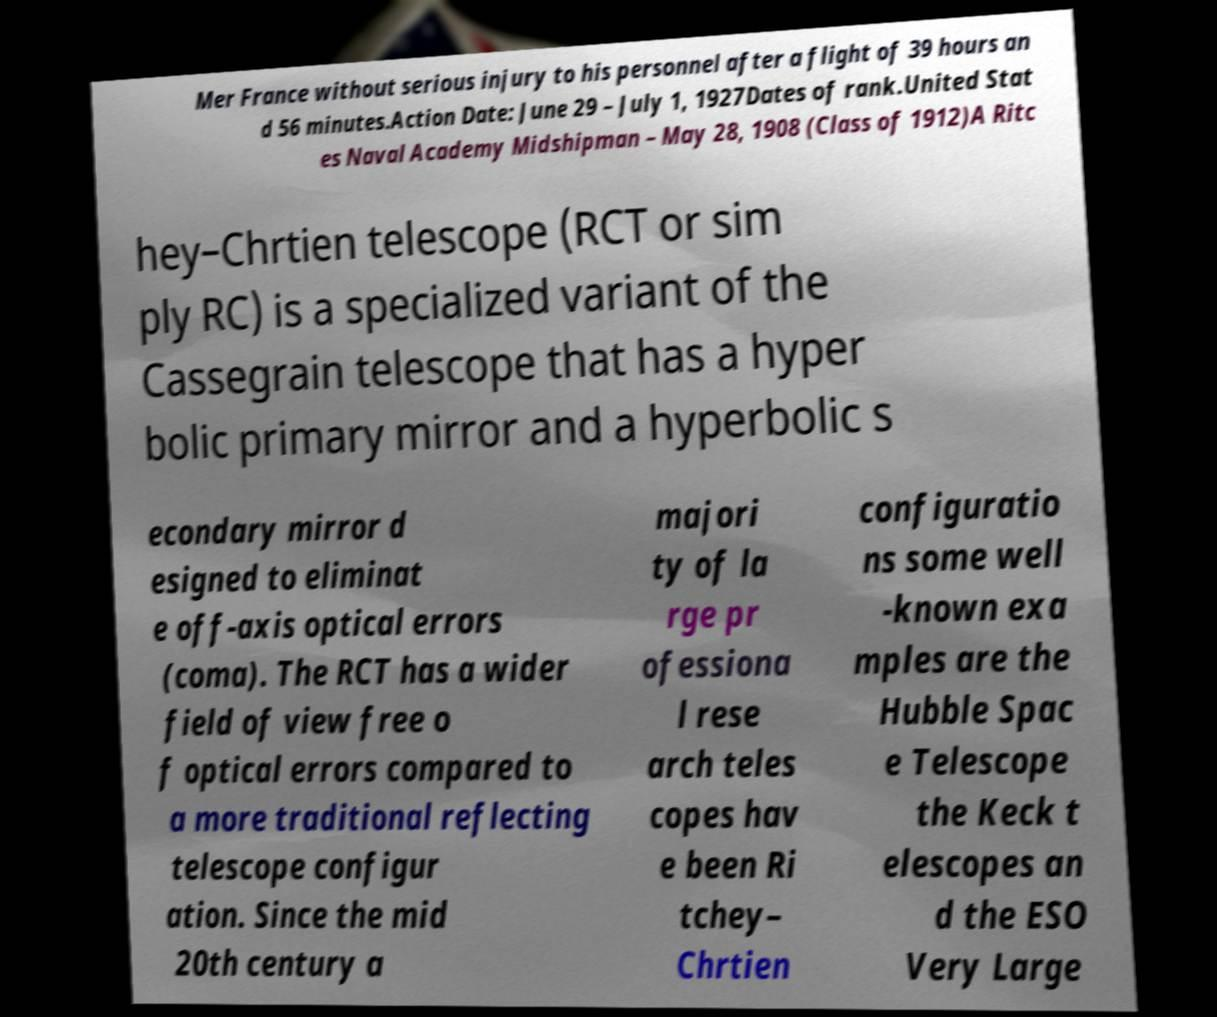Please identify and transcribe the text found in this image. Mer France without serious injury to his personnel after a flight of 39 hours an d 56 minutes.Action Date: June 29 – July 1, 1927Dates of rank.United Stat es Naval Academy Midshipman – May 28, 1908 (Class of 1912)A Ritc hey–Chrtien telescope (RCT or sim ply RC) is a specialized variant of the Cassegrain telescope that has a hyper bolic primary mirror and a hyperbolic s econdary mirror d esigned to eliminat e off-axis optical errors (coma). The RCT has a wider field of view free o f optical errors compared to a more traditional reflecting telescope configur ation. Since the mid 20th century a majori ty of la rge pr ofessiona l rese arch teles copes hav e been Ri tchey– Chrtien configuratio ns some well -known exa mples are the Hubble Spac e Telescope the Keck t elescopes an d the ESO Very Large 